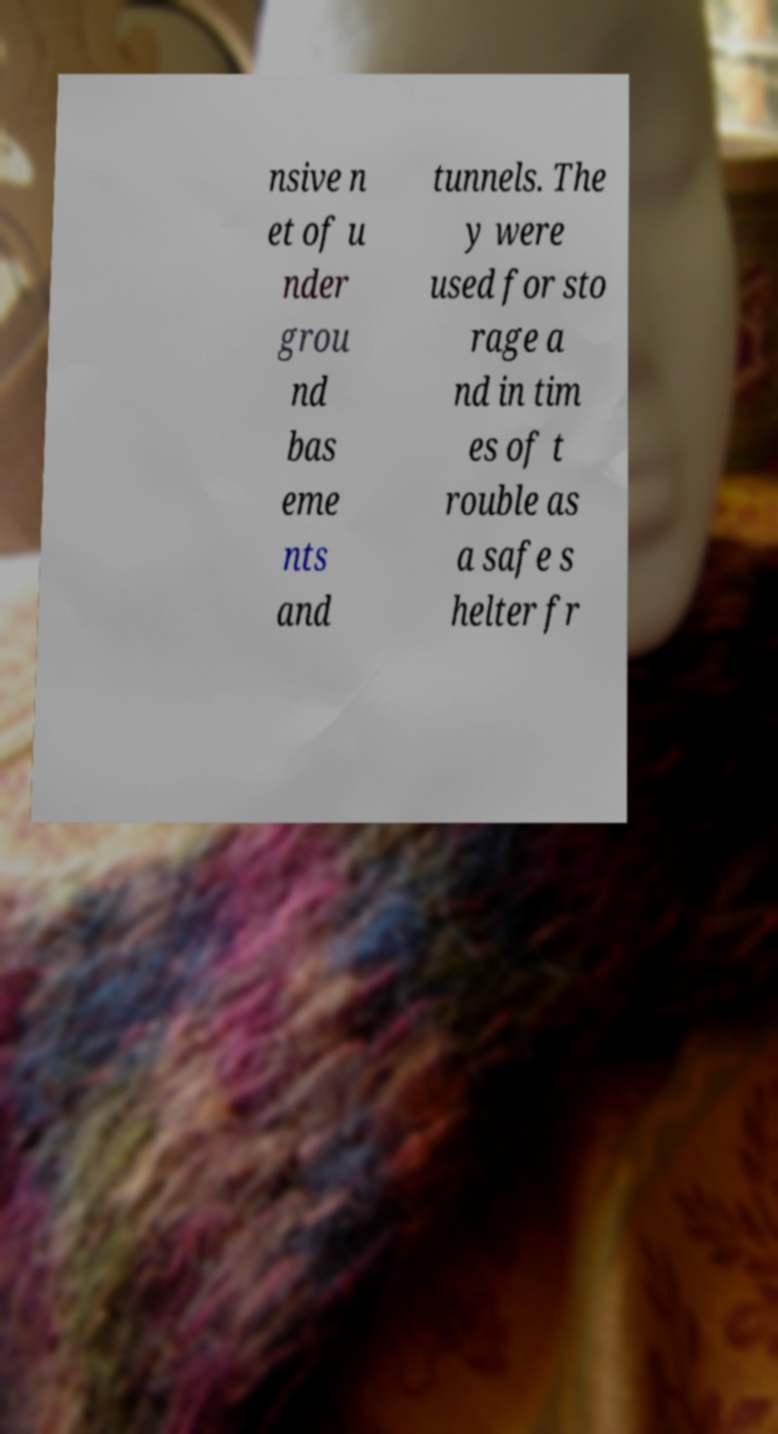I need the written content from this picture converted into text. Can you do that? nsive n et of u nder grou nd bas eme nts and tunnels. The y were used for sto rage a nd in tim es of t rouble as a safe s helter fr 